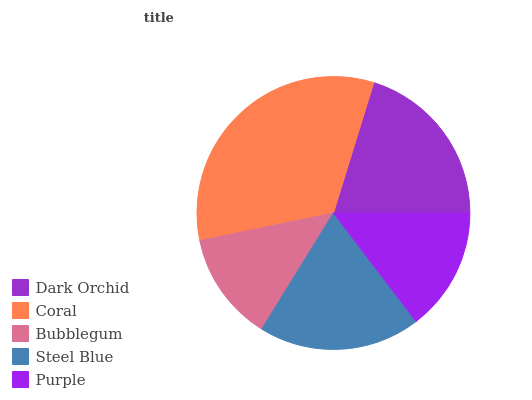Is Bubblegum the minimum?
Answer yes or no. Yes. Is Coral the maximum?
Answer yes or no. Yes. Is Coral the minimum?
Answer yes or no. No. Is Bubblegum the maximum?
Answer yes or no. No. Is Coral greater than Bubblegum?
Answer yes or no. Yes. Is Bubblegum less than Coral?
Answer yes or no. Yes. Is Bubblegum greater than Coral?
Answer yes or no. No. Is Coral less than Bubblegum?
Answer yes or no. No. Is Steel Blue the high median?
Answer yes or no. Yes. Is Steel Blue the low median?
Answer yes or no. Yes. Is Coral the high median?
Answer yes or no. No. Is Dark Orchid the low median?
Answer yes or no. No. 